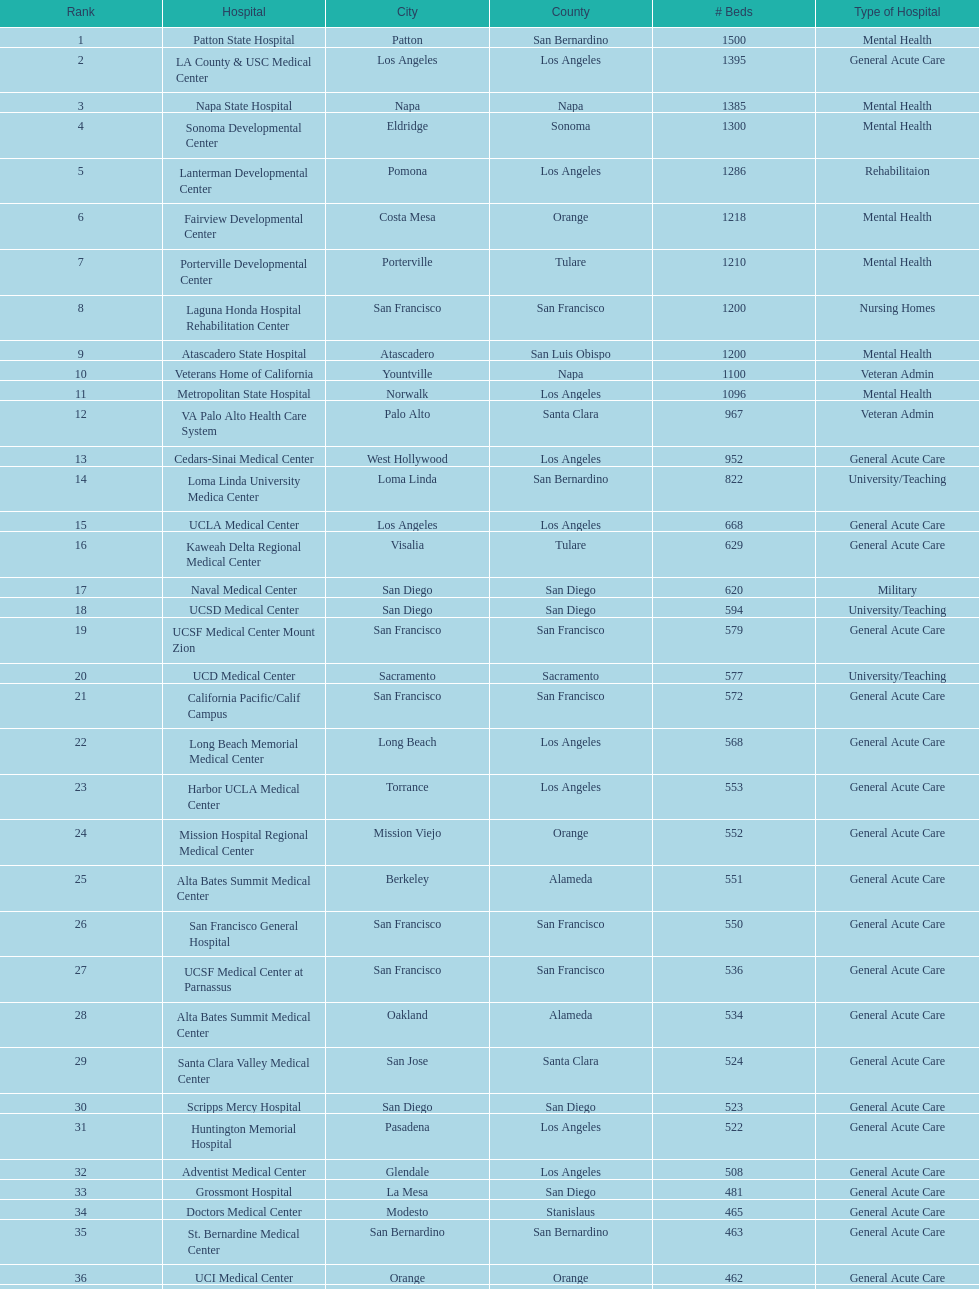What is the difference in the number of general acute care hospitals and rehabilitation hospitals in california? 33. 